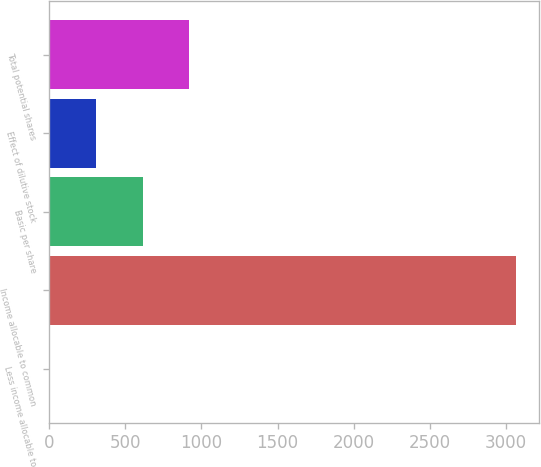Convert chart to OTSL. <chart><loc_0><loc_0><loc_500><loc_500><bar_chart><fcel>Less income allocable to<fcel>Income allocable to common<fcel>Basic per share<fcel>Effect of dilutive stock<fcel>Total potential shares<nl><fcel>0.8<fcel>3063.9<fcel>613.42<fcel>307.11<fcel>919.73<nl></chart> 